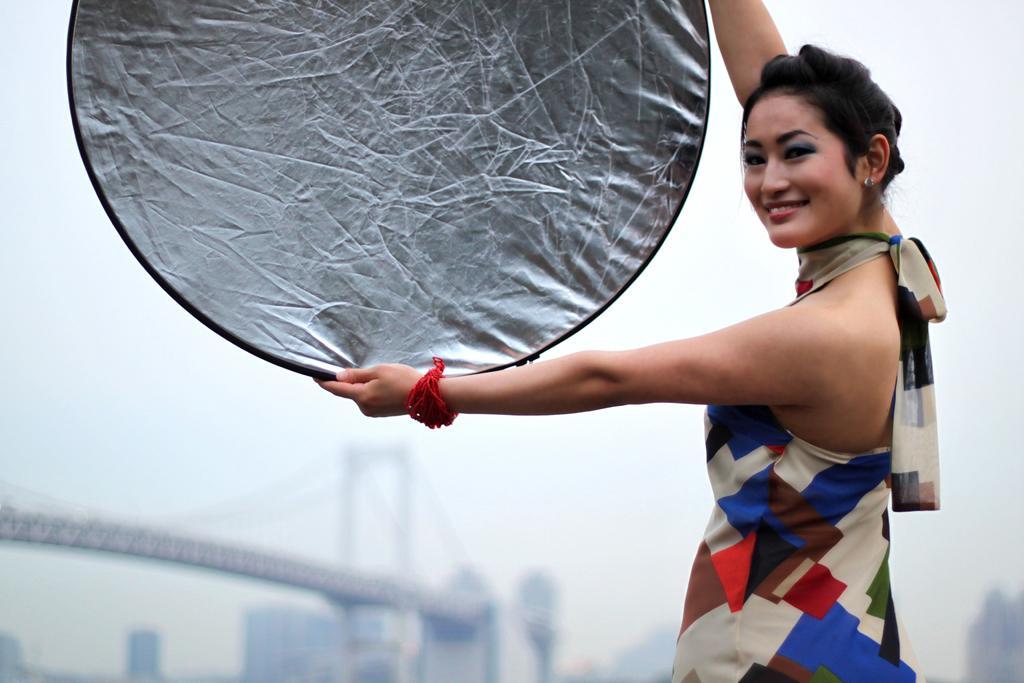Describe this image in one or two sentences. In this image we can see a woman is holding some circular shaped object in her hand and she is wearing blue, red and cream color dress. In the background, we can see buildings and the bridge. 